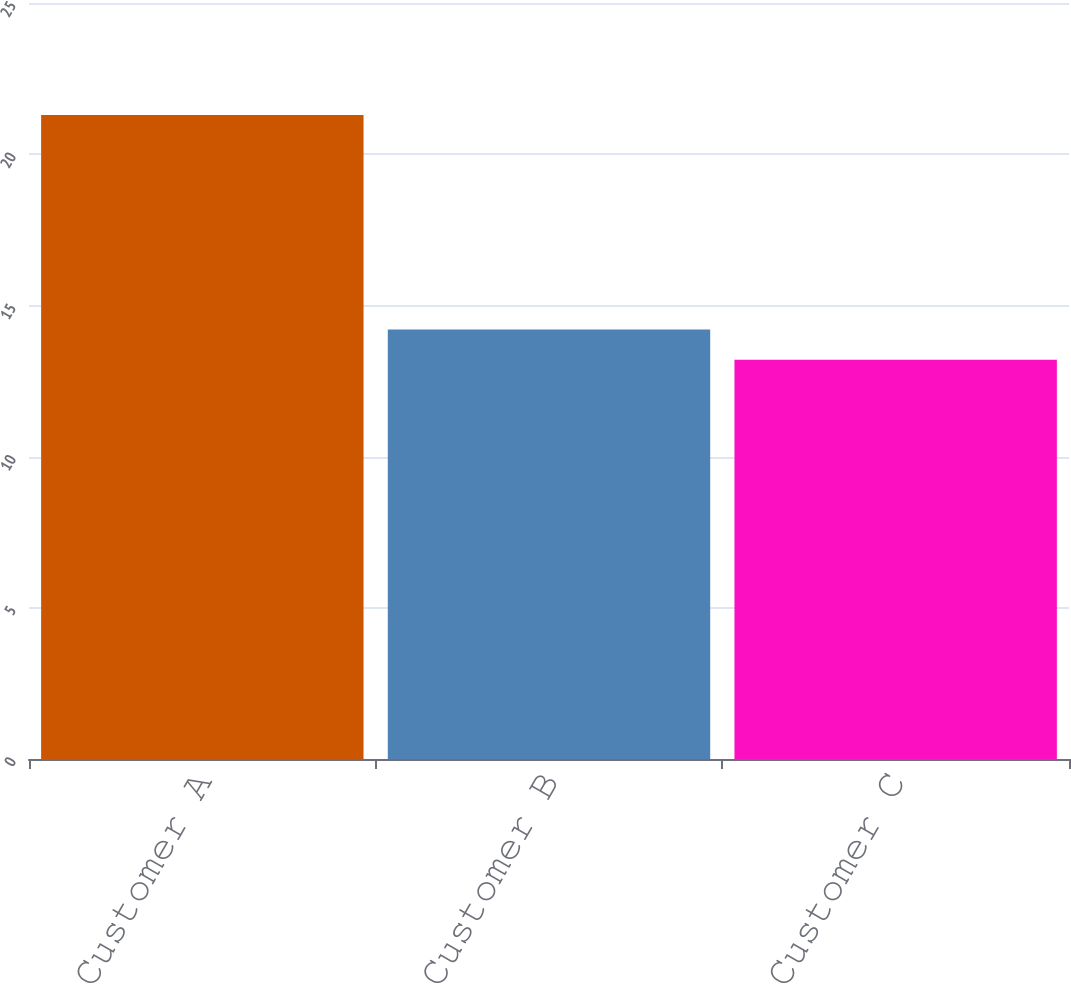Convert chart. <chart><loc_0><loc_0><loc_500><loc_500><bar_chart><fcel>Customer A<fcel>Customer B<fcel>Customer C<nl><fcel>21.3<fcel>14.2<fcel>13.2<nl></chart> 